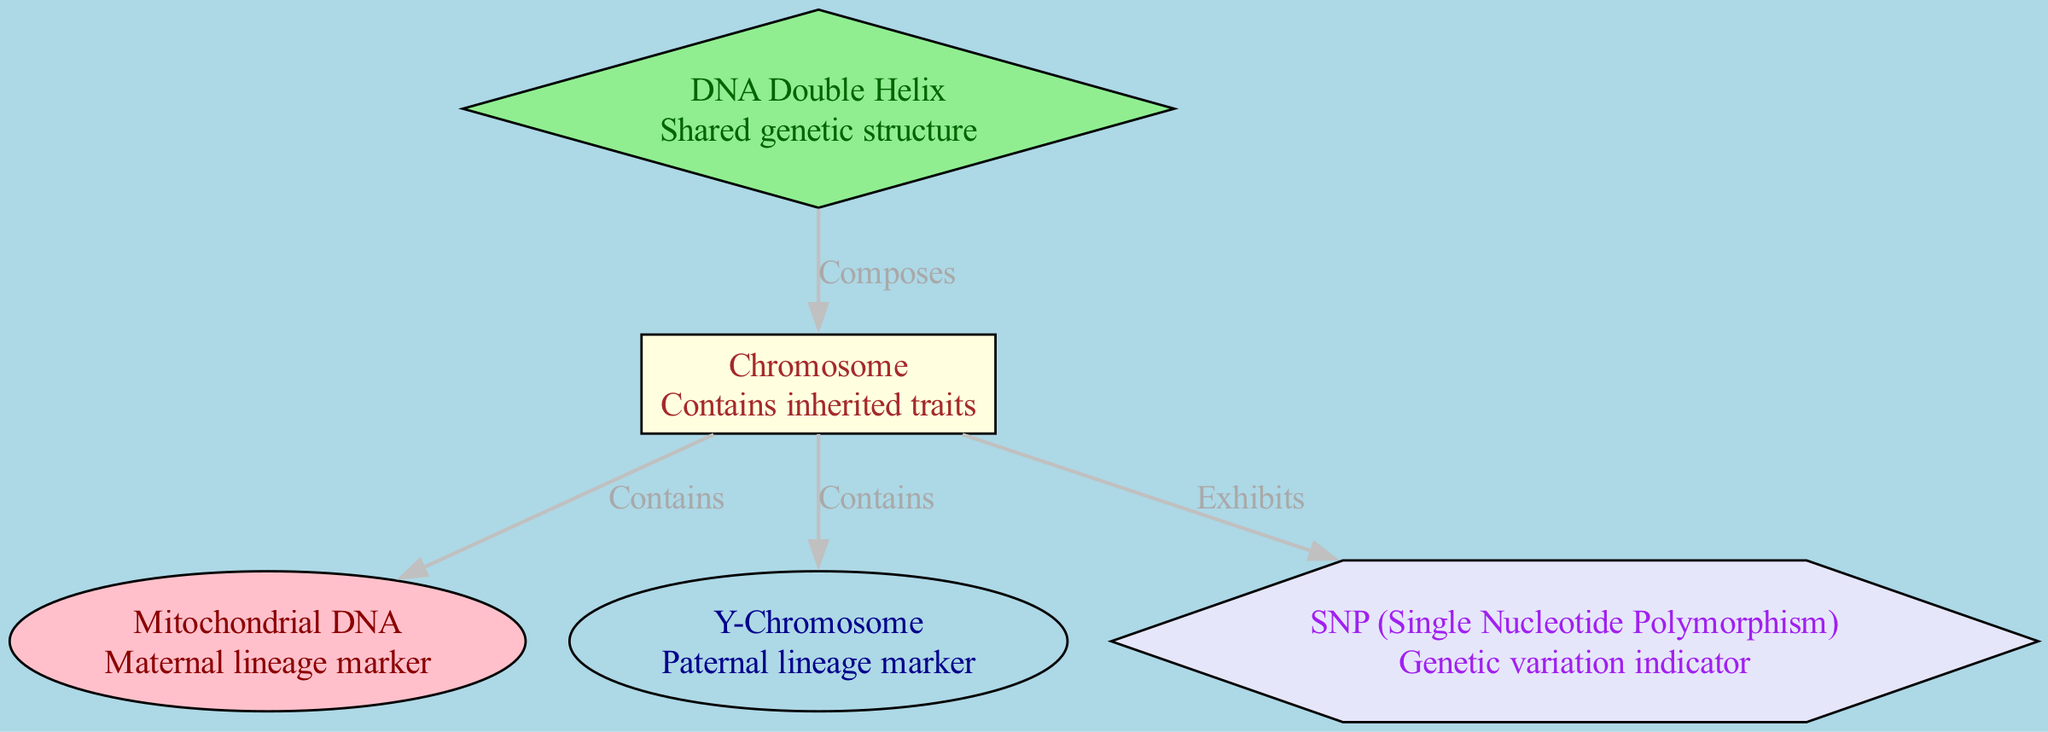What is the basic structure of the genetic material depicted in the diagram? The diagram shows a "DNA Double Helix," which is described as the shared genetic structure, representing the fundamental configuration of genetic material.
Answer: DNA Double Helix What shape is used to represent the Y-Chromosome? The Y-Chromosome is represented by an "ellipse" shape, which is consistent with the visual coding for chromosome-related markers in the diagram.
Answer: ellipse How many nodes are in the diagram? By counting each distinct labeled component in the nodes list, we find there are five nodes, representing various elements of genetic material and markers.
Answer: 5 What labels are the connections between DNA Double Helix and Chromosome? The connection between "DNA Double Helix" and "Chromosome" is labeled as "Composes," indicating that the DNA Double Helix forms the structural basis of chromosomes.
Answer: Composes What is the role of Mitochondrial DNA in the context of genetic lineage? Mitochondrial DNA serves as a "Maternal lineage marker," indicating its significance for tracing maternal ancestry through the inheritance of these genetic markers.
Answer: Maternal lineage marker What two elements does the Chromosome contain as indicated in the diagram? The Chromosome contains both "Mitochondrial DNA" and "Y-Chromosome," as indicated by the edges labeled "Contains," showing the components that are part of the chromosome structure.
Answer: Mitochondrial DNA, Y-Chromosome Which form of DNA is shown to exhibit genetic variations? The diagram identifies SNP (Single Nucleotide Polymorphism) as the element that "Exhibits" genetic variations, suggesting its role in identifying genetic diversity.
Answer: SNP What color is the node representing DNA Double Helix? The DNA Double Helix node is filled with "lightgreen," which is specified in the visual attributes of the nodes in the diagram.
Answer: lightgreen 